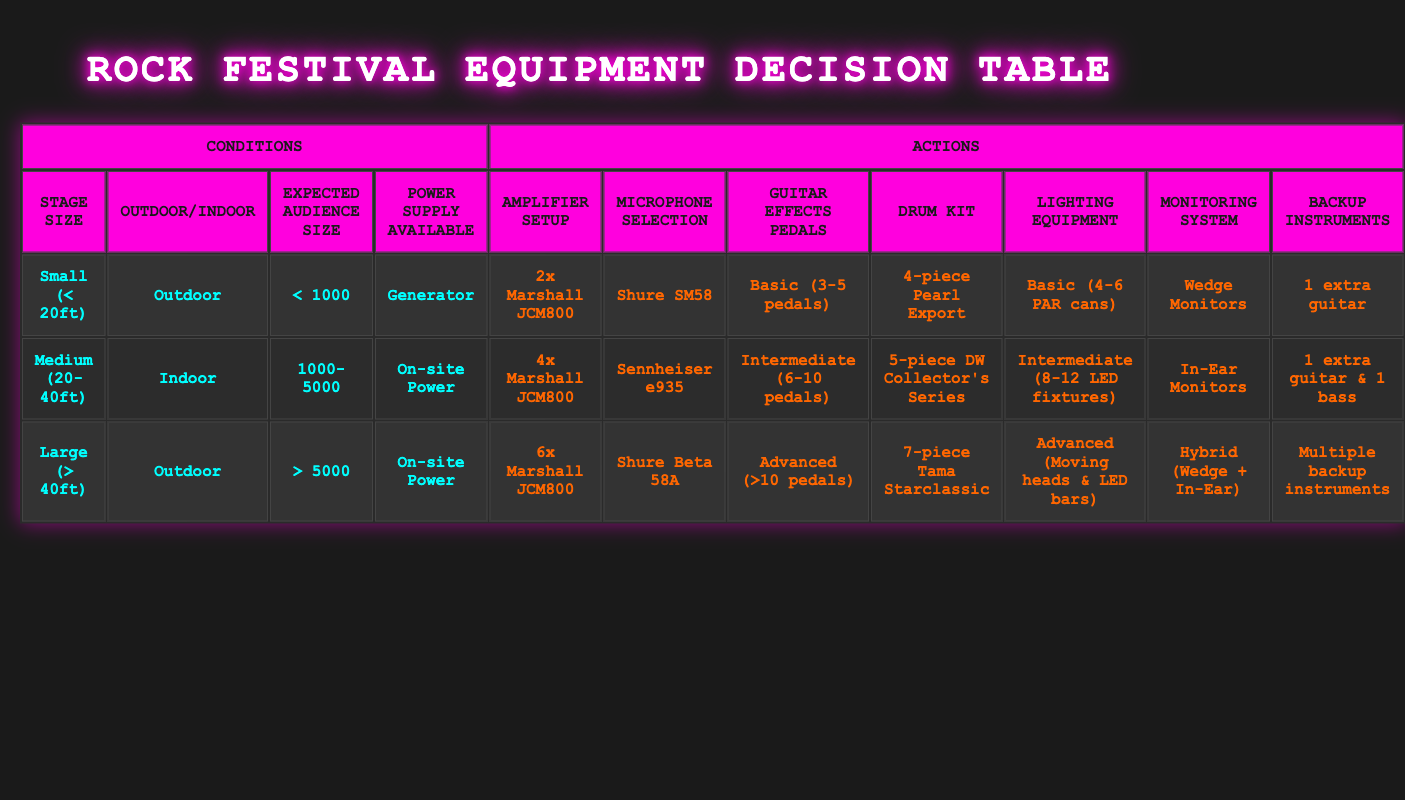What amplifier setup is recommended for a Medium stage size at an indoor festival? For a Medium stage size (20-40ft) at an indoor festival, the table specifies the amplifier setup should be 4x Marshall JCM800.
Answer: 4x Marshall JCM800 True or False: A Large stage size with outdoor settings requires a 5-piece DW Collector's Series drum kit. For a Large stage size (> 40ft) outdoors, the drum kit specified in the table is 7-piece Tama Starclassic. Since it does not require a 5-piece drum kit, the answer is false.
Answer: False What is the recommended monitoring system for a Small stage size at an outdoor festival with an expected audience size less than 1000? The table shows that for a Small stage size (< 20ft) at an outdoor festival with an audience size of less than 1000, the recommended monitoring system is Wedge Monitors.
Answer: Wedge Monitors What is the difference in the number of guitar effects pedals recommended for a Medium stage size and a Large stage size performance? The Medium stage size (20-40ft) requires Intermediate (6-10 pedals) while the Large stage size (> 40ft) requires Advanced (>10 pedals). The difference in the number of pedals is more than 10 - (6 to 10).
Answer: More than 10 Which microphone is suggested for a Large outdoor festival with an audience size greater than 5000? The table indicates that for a Large stage size (> 40ft) outdoors with more than 5000 audience size, the microphone suggested is Shure Beta 58A.
Answer: Shure Beta 58A For an outdoor festival with a Medium stage size and an audience between 1000-5000, what lighting equipment is recommended? In the case of a Medium stage size (20-40ft) outdoors with an audience size between 1000-5000, the recommended lighting equipment is Intermediate (8-12 LED fixtures) according to the table.
Answer: Intermediate (8-12 LED fixtures) Is it necessary to have multiple backup instruments for an indoor festival performance at a Large stage size? The table states that a Large stage size (> 40ft) performance requires multiple backup instruments, which confirms it is necessary.
Answer: Yes What is the average number of backup instruments needed when performing on a Small and Medium stage size? The Small stage requires 1 extra guitar and the Medium stage requires 1 extra guitar & 1 bass. To find an average: (1 + 2) / 2 = 1.5, meaning the average is 1.5 backup instruments.
Answer: 1.5 